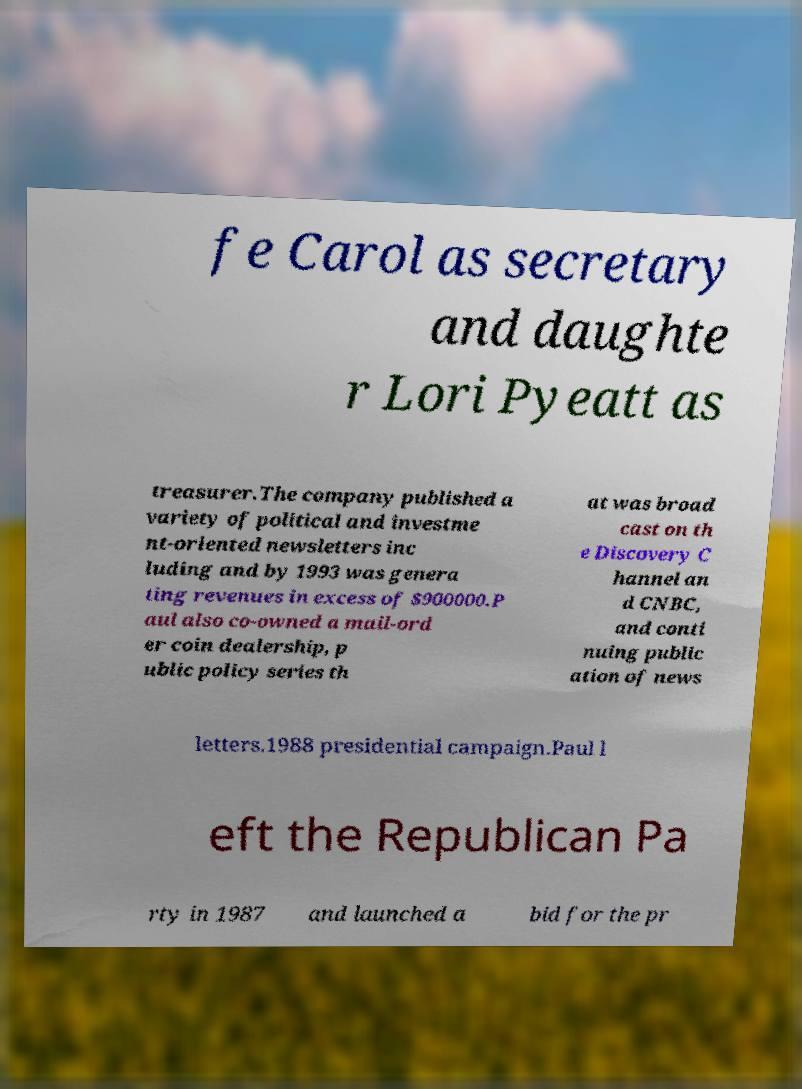I need the written content from this picture converted into text. Can you do that? fe Carol as secretary and daughte r Lori Pyeatt as treasurer.The company published a variety of political and investme nt-oriented newsletters inc luding and by 1993 was genera ting revenues in excess of $900000.P aul also co-owned a mail-ord er coin dealership, p ublic policy series th at was broad cast on th e Discovery C hannel an d CNBC, and conti nuing public ation of news letters.1988 presidential campaign.Paul l eft the Republican Pa rty in 1987 and launched a bid for the pr 